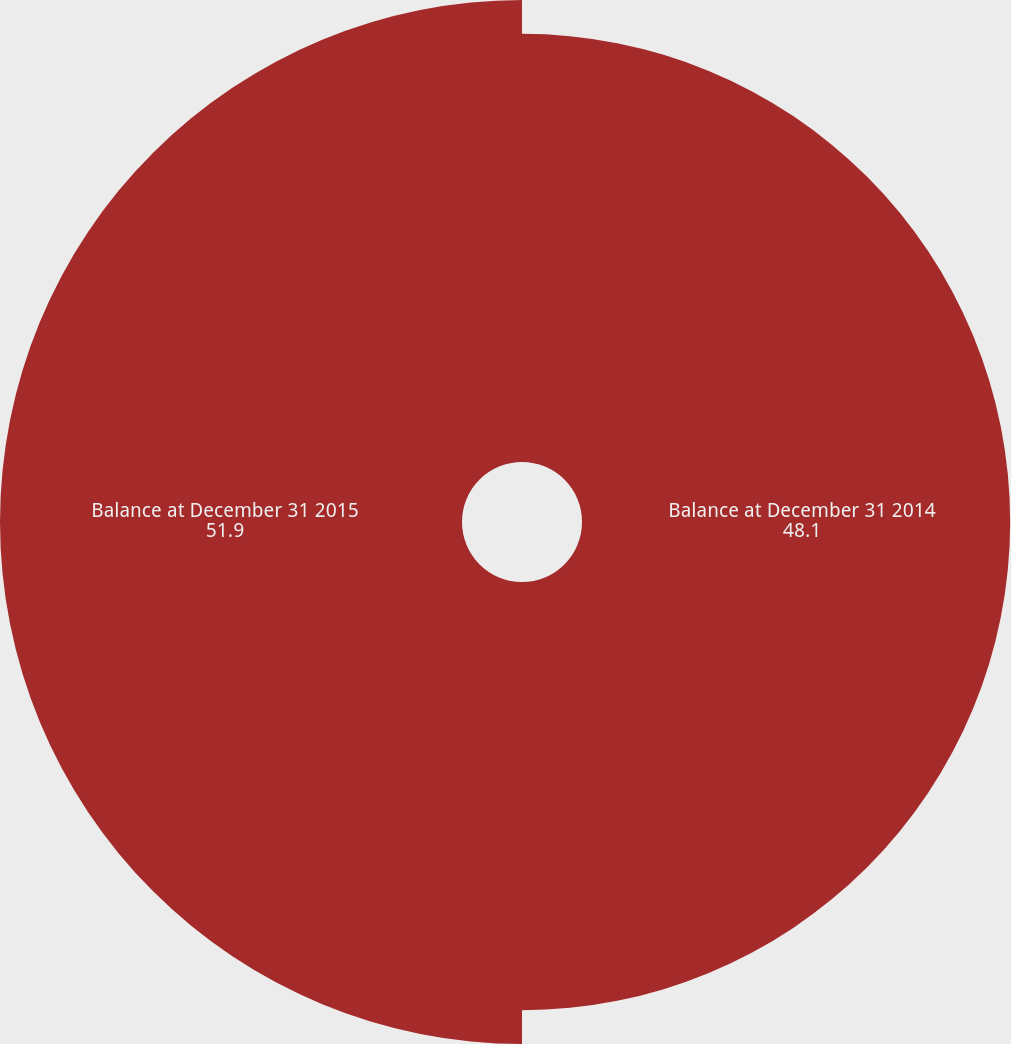Convert chart to OTSL. <chart><loc_0><loc_0><loc_500><loc_500><pie_chart><fcel>Balance at December 31 2014<fcel>Balance at December 31 2015<nl><fcel>48.1%<fcel>51.9%<nl></chart> 